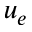Convert formula to latex. <formula><loc_0><loc_0><loc_500><loc_500>u _ { e }</formula> 